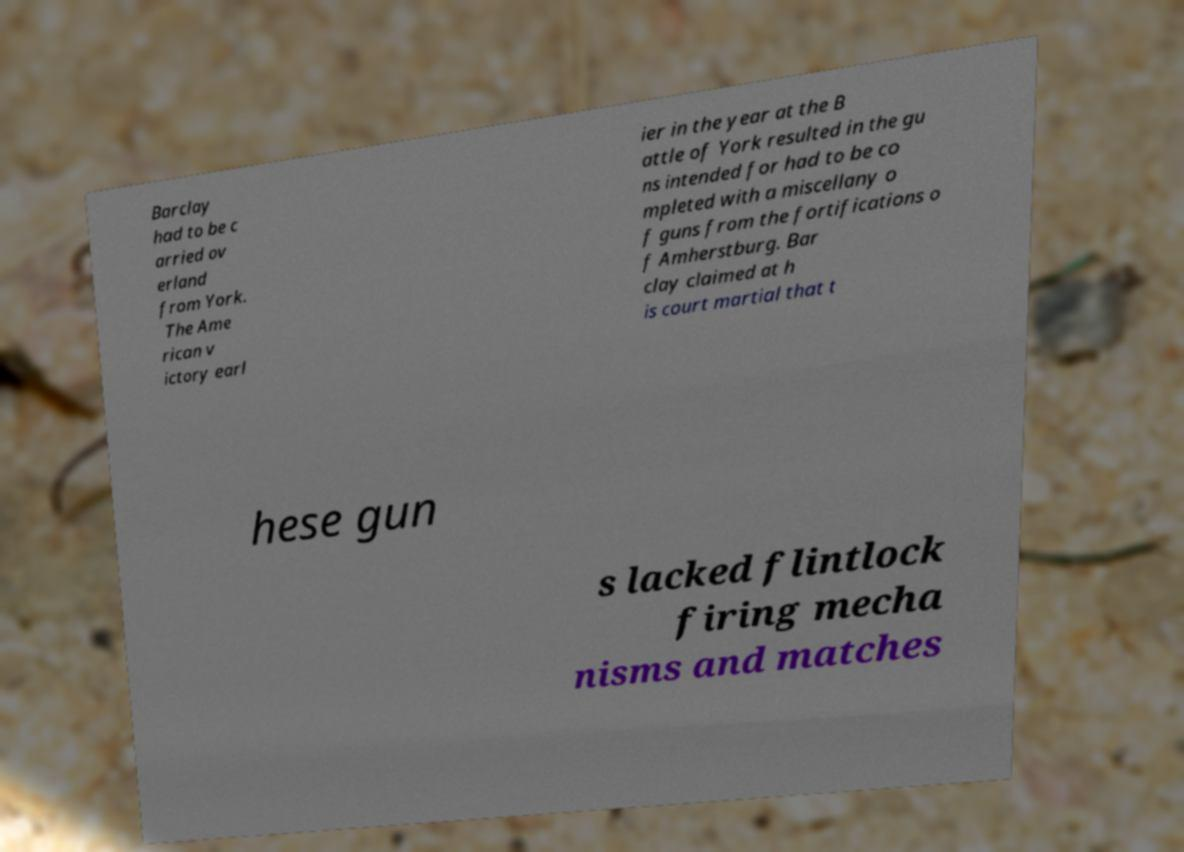Can you read and provide the text displayed in the image?This photo seems to have some interesting text. Can you extract and type it out for me? Barclay had to be c arried ov erland from York. The Ame rican v ictory earl ier in the year at the B attle of York resulted in the gu ns intended for had to be co mpleted with a miscellany o f guns from the fortifications o f Amherstburg. Bar clay claimed at h is court martial that t hese gun s lacked flintlock firing mecha nisms and matches 